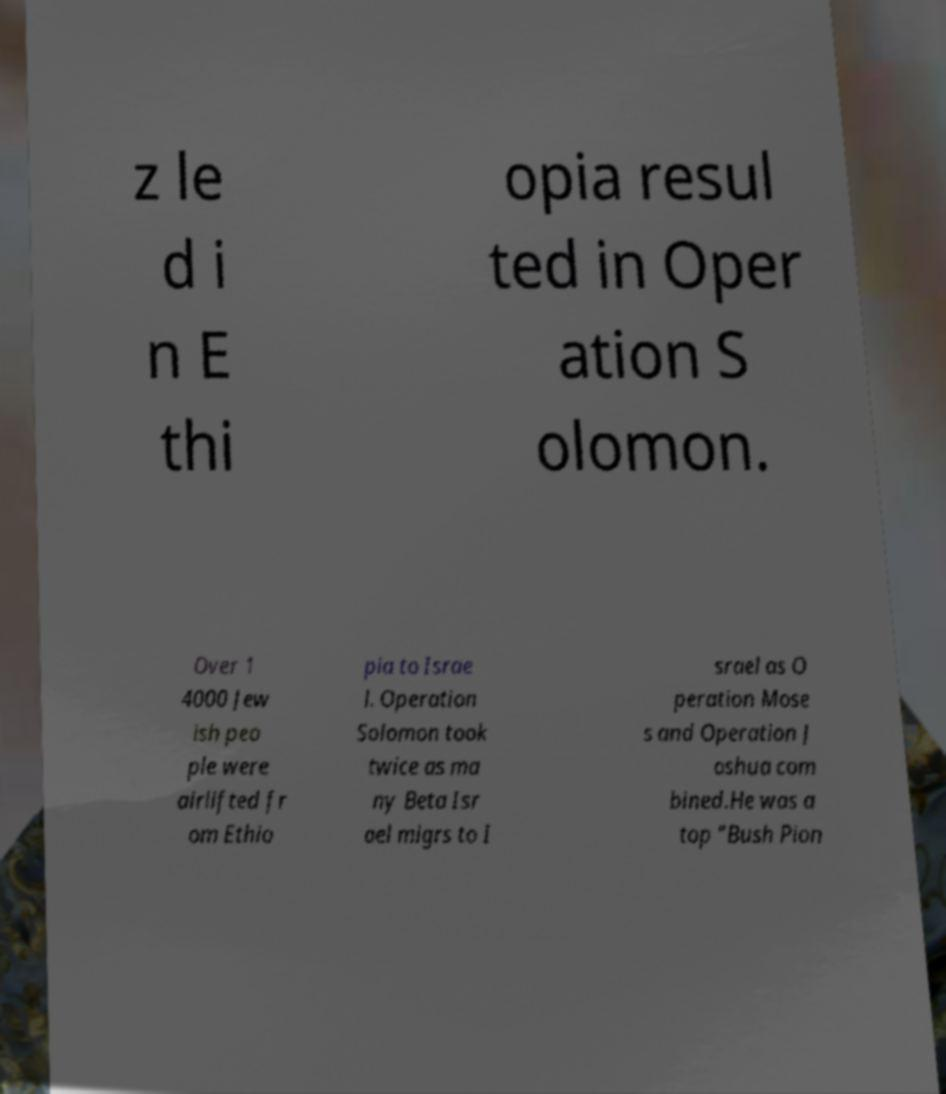What messages or text are displayed in this image? I need them in a readable, typed format. z le d i n E thi opia resul ted in Oper ation S olomon. Over 1 4000 Jew ish peo ple were airlifted fr om Ethio pia to Israe l. Operation Solomon took twice as ma ny Beta Isr ael migrs to I srael as O peration Mose s and Operation J oshua com bined.He was a top "Bush Pion 